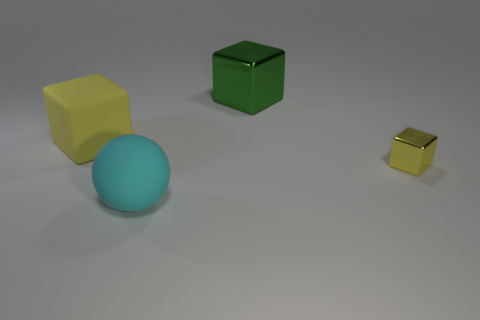Is there any other thing that is the same size as the yellow metal object?
Give a very brief answer. No. How many objects are either big objects in front of the big rubber cube or yellow things on the left side of the big sphere?
Your response must be concise. 2. There is a matte object left of the large rubber sphere; is it the same color as the large block on the right side of the big cyan sphere?
Your answer should be very brief. No. There is a thing that is to the right of the big yellow rubber cube and to the left of the green shiny cube; what shape is it?
Give a very brief answer. Sphere. There is another metallic thing that is the same size as the cyan thing; what color is it?
Ensure brevity in your answer.  Green. Are there any tiny things that have the same color as the matte cube?
Your answer should be very brief. Yes. There is a shiny block that is on the left side of the yellow metal cube; is its size the same as the yellow object right of the cyan rubber ball?
Give a very brief answer. No. There is a object that is behind the small yellow metallic object and left of the green metal block; what material is it?
Provide a short and direct response. Rubber. What is the size of the thing that is the same color as the tiny block?
Keep it short and to the point. Large. How many other objects are the same size as the ball?
Provide a short and direct response. 2. 